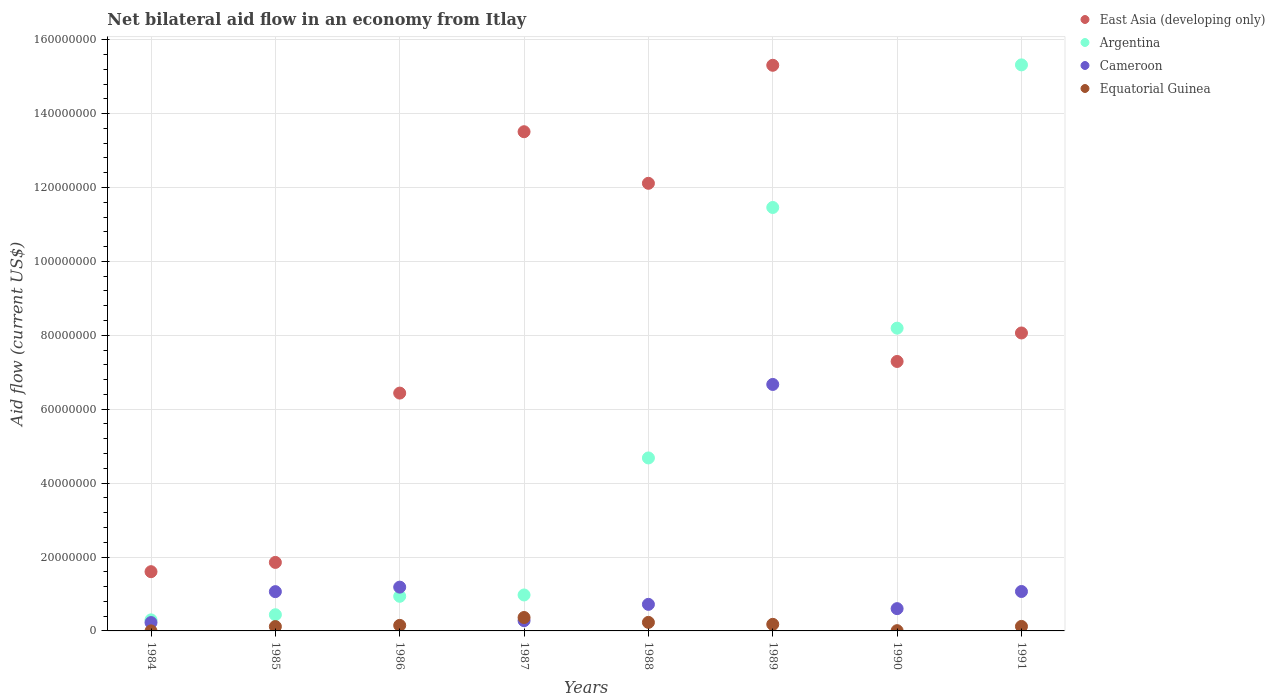How many different coloured dotlines are there?
Your response must be concise. 4. What is the net bilateral aid flow in Equatorial Guinea in 1990?
Give a very brief answer. 7.00e+04. Across all years, what is the maximum net bilateral aid flow in Argentina?
Offer a terse response. 1.53e+08. Across all years, what is the minimum net bilateral aid flow in East Asia (developing only)?
Ensure brevity in your answer.  1.60e+07. In which year was the net bilateral aid flow in Equatorial Guinea maximum?
Offer a very short reply. 1987. What is the total net bilateral aid flow in Cameroon in the graph?
Offer a terse response. 1.18e+08. What is the difference between the net bilateral aid flow in Cameroon in 1984 and that in 1991?
Provide a succinct answer. -8.41e+06. What is the difference between the net bilateral aid flow in Equatorial Guinea in 1991 and the net bilateral aid flow in East Asia (developing only) in 1989?
Make the answer very short. -1.52e+08. What is the average net bilateral aid flow in Cameroon per year?
Provide a succinct answer. 1.48e+07. In the year 1988, what is the difference between the net bilateral aid flow in East Asia (developing only) and net bilateral aid flow in Cameroon?
Make the answer very short. 1.14e+08. In how many years, is the net bilateral aid flow in East Asia (developing only) greater than 152000000 US$?
Your response must be concise. 1. What is the ratio of the net bilateral aid flow in Equatorial Guinea in 1986 to that in 1988?
Give a very brief answer. 0.65. What is the difference between the highest and the second highest net bilateral aid flow in Equatorial Guinea?
Your response must be concise. 1.32e+06. What is the difference between the highest and the lowest net bilateral aid flow in Argentina?
Make the answer very short. 1.50e+08. Is it the case that in every year, the sum of the net bilateral aid flow in East Asia (developing only) and net bilateral aid flow in Equatorial Guinea  is greater than the sum of net bilateral aid flow in Cameroon and net bilateral aid flow in Argentina?
Keep it short and to the point. No. Is the net bilateral aid flow in Equatorial Guinea strictly greater than the net bilateral aid flow in Cameroon over the years?
Ensure brevity in your answer.  No. How many dotlines are there?
Offer a terse response. 4. How many years are there in the graph?
Your answer should be very brief. 8. How many legend labels are there?
Give a very brief answer. 4. How are the legend labels stacked?
Offer a terse response. Vertical. What is the title of the graph?
Give a very brief answer. Net bilateral aid flow in an economy from Itlay. What is the label or title of the X-axis?
Make the answer very short. Years. What is the Aid flow (current US$) of East Asia (developing only) in 1984?
Provide a short and direct response. 1.60e+07. What is the Aid flow (current US$) in Argentina in 1984?
Keep it short and to the point. 2.99e+06. What is the Aid flow (current US$) of Cameroon in 1984?
Your answer should be compact. 2.26e+06. What is the Aid flow (current US$) of East Asia (developing only) in 1985?
Ensure brevity in your answer.  1.85e+07. What is the Aid flow (current US$) of Argentina in 1985?
Your response must be concise. 4.38e+06. What is the Aid flow (current US$) in Cameroon in 1985?
Make the answer very short. 1.06e+07. What is the Aid flow (current US$) in Equatorial Guinea in 1985?
Provide a short and direct response. 1.18e+06. What is the Aid flow (current US$) of East Asia (developing only) in 1986?
Provide a succinct answer. 6.44e+07. What is the Aid flow (current US$) of Argentina in 1986?
Keep it short and to the point. 9.37e+06. What is the Aid flow (current US$) of Cameroon in 1986?
Keep it short and to the point. 1.18e+07. What is the Aid flow (current US$) of Equatorial Guinea in 1986?
Make the answer very short. 1.50e+06. What is the Aid flow (current US$) of East Asia (developing only) in 1987?
Provide a succinct answer. 1.35e+08. What is the Aid flow (current US$) of Argentina in 1987?
Provide a short and direct response. 9.73e+06. What is the Aid flow (current US$) in Cameroon in 1987?
Your answer should be very brief. 2.77e+06. What is the Aid flow (current US$) in Equatorial Guinea in 1987?
Make the answer very short. 3.63e+06. What is the Aid flow (current US$) of East Asia (developing only) in 1988?
Your response must be concise. 1.21e+08. What is the Aid flow (current US$) of Argentina in 1988?
Make the answer very short. 4.68e+07. What is the Aid flow (current US$) of Cameroon in 1988?
Offer a terse response. 7.19e+06. What is the Aid flow (current US$) in Equatorial Guinea in 1988?
Your answer should be very brief. 2.31e+06. What is the Aid flow (current US$) of East Asia (developing only) in 1989?
Give a very brief answer. 1.53e+08. What is the Aid flow (current US$) of Argentina in 1989?
Give a very brief answer. 1.15e+08. What is the Aid flow (current US$) of Cameroon in 1989?
Keep it short and to the point. 6.67e+07. What is the Aid flow (current US$) in Equatorial Guinea in 1989?
Your answer should be compact. 1.78e+06. What is the Aid flow (current US$) in East Asia (developing only) in 1990?
Ensure brevity in your answer.  7.29e+07. What is the Aid flow (current US$) of Argentina in 1990?
Your answer should be compact. 8.19e+07. What is the Aid flow (current US$) of Cameroon in 1990?
Make the answer very short. 6.03e+06. What is the Aid flow (current US$) in Equatorial Guinea in 1990?
Offer a very short reply. 7.00e+04. What is the Aid flow (current US$) in East Asia (developing only) in 1991?
Offer a terse response. 8.06e+07. What is the Aid flow (current US$) in Argentina in 1991?
Offer a very short reply. 1.53e+08. What is the Aid flow (current US$) of Cameroon in 1991?
Your response must be concise. 1.07e+07. What is the Aid flow (current US$) in Equatorial Guinea in 1991?
Your answer should be compact. 1.22e+06. Across all years, what is the maximum Aid flow (current US$) of East Asia (developing only)?
Give a very brief answer. 1.53e+08. Across all years, what is the maximum Aid flow (current US$) in Argentina?
Offer a very short reply. 1.53e+08. Across all years, what is the maximum Aid flow (current US$) in Cameroon?
Your response must be concise. 6.67e+07. Across all years, what is the maximum Aid flow (current US$) in Equatorial Guinea?
Your answer should be compact. 3.63e+06. Across all years, what is the minimum Aid flow (current US$) of East Asia (developing only)?
Give a very brief answer. 1.60e+07. Across all years, what is the minimum Aid flow (current US$) in Argentina?
Offer a terse response. 2.99e+06. Across all years, what is the minimum Aid flow (current US$) in Cameroon?
Make the answer very short. 2.26e+06. Across all years, what is the minimum Aid flow (current US$) of Equatorial Guinea?
Give a very brief answer. 10000. What is the total Aid flow (current US$) in East Asia (developing only) in the graph?
Make the answer very short. 6.62e+08. What is the total Aid flow (current US$) of Argentina in the graph?
Your response must be concise. 4.23e+08. What is the total Aid flow (current US$) in Cameroon in the graph?
Give a very brief answer. 1.18e+08. What is the total Aid flow (current US$) of Equatorial Guinea in the graph?
Offer a terse response. 1.17e+07. What is the difference between the Aid flow (current US$) of East Asia (developing only) in 1984 and that in 1985?
Provide a short and direct response. -2.51e+06. What is the difference between the Aid flow (current US$) of Argentina in 1984 and that in 1985?
Provide a short and direct response. -1.39e+06. What is the difference between the Aid flow (current US$) of Cameroon in 1984 and that in 1985?
Your answer should be compact. -8.37e+06. What is the difference between the Aid flow (current US$) in Equatorial Guinea in 1984 and that in 1985?
Offer a terse response. -1.17e+06. What is the difference between the Aid flow (current US$) in East Asia (developing only) in 1984 and that in 1986?
Offer a very short reply. -4.83e+07. What is the difference between the Aid flow (current US$) of Argentina in 1984 and that in 1986?
Your answer should be very brief. -6.38e+06. What is the difference between the Aid flow (current US$) in Cameroon in 1984 and that in 1986?
Offer a terse response. -9.59e+06. What is the difference between the Aid flow (current US$) in Equatorial Guinea in 1984 and that in 1986?
Offer a terse response. -1.49e+06. What is the difference between the Aid flow (current US$) in East Asia (developing only) in 1984 and that in 1987?
Provide a short and direct response. -1.19e+08. What is the difference between the Aid flow (current US$) in Argentina in 1984 and that in 1987?
Offer a very short reply. -6.74e+06. What is the difference between the Aid flow (current US$) of Cameroon in 1984 and that in 1987?
Make the answer very short. -5.10e+05. What is the difference between the Aid flow (current US$) in Equatorial Guinea in 1984 and that in 1987?
Keep it short and to the point. -3.62e+06. What is the difference between the Aid flow (current US$) of East Asia (developing only) in 1984 and that in 1988?
Ensure brevity in your answer.  -1.05e+08. What is the difference between the Aid flow (current US$) in Argentina in 1984 and that in 1988?
Offer a terse response. -4.38e+07. What is the difference between the Aid flow (current US$) in Cameroon in 1984 and that in 1988?
Offer a very short reply. -4.93e+06. What is the difference between the Aid flow (current US$) in Equatorial Guinea in 1984 and that in 1988?
Give a very brief answer. -2.30e+06. What is the difference between the Aid flow (current US$) of East Asia (developing only) in 1984 and that in 1989?
Offer a very short reply. -1.37e+08. What is the difference between the Aid flow (current US$) of Argentina in 1984 and that in 1989?
Ensure brevity in your answer.  -1.12e+08. What is the difference between the Aid flow (current US$) in Cameroon in 1984 and that in 1989?
Provide a succinct answer. -6.44e+07. What is the difference between the Aid flow (current US$) in Equatorial Guinea in 1984 and that in 1989?
Your response must be concise. -1.77e+06. What is the difference between the Aid flow (current US$) of East Asia (developing only) in 1984 and that in 1990?
Your answer should be very brief. -5.69e+07. What is the difference between the Aid flow (current US$) in Argentina in 1984 and that in 1990?
Give a very brief answer. -7.89e+07. What is the difference between the Aid flow (current US$) of Cameroon in 1984 and that in 1990?
Make the answer very short. -3.77e+06. What is the difference between the Aid flow (current US$) of Equatorial Guinea in 1984 and that in 1990?
Provide a short and direct response. -6.00e+04. What is the difference between the Aid flow (current US$) in East Asia (developing only) in 1984 and that in 1991?
Offer a very short reply. -6.46e+07. What is the difference between the Aid flow (current US$) of Argentina in 1984 and that in 1991?
Offer a very short reply. -1.50e+08. What is the difference between the Aid flow (current US$) in Cameroon in 1984 and that in 1991?
Provide a succinct answer. -8.41e+06. What is the difference between the Aid flow (current US$) in Equatorial Guinea in 1984 and that in 1991?
Provide a short and direct response. -1.21e+06. What is the difference between the Aid flow (current US$) of East Asia (developing only) in 1985 and that in 1986?
Your response must be concise. -4.58e+07. What is the difference between the Aid flow (current US$) in Argentina in 1985 and that in 1986?
Ensure brevity in your answer.  -4.99e+06. What is the difference between the Aid flow (current US$) in Cameroon in 1985 and that in 1986?
Your response must be concise. -1.22e+06. What is the difference between the Aid flow (current US$) in Equatorial Guinea in 1985 and that in 1986?
Provide a short and direct response. -3.20e+05. What is the difference between the Aid flow (current US$) of East Asia (developing only) in 1985 and that in 1987?
Keep it short and to the point. -1.17e+08. What is the difference between the Aid flow (current US$) in Argentina in 1985 and that in 1987?
Your response must be concise. -5.35e+06. What is the difference between the Aid flow (current US$) of Cameroon in 1985 and that in 1987?
Ensure brevity in your answer.  7.86e+06. What is the difference between the Aid flow (current US$) of Equatorial Guinea in 1985 and that in 1987?
Your response must be concise. -2.45e+06. What is the difference between the Aid flow (current US$) of East Asia (developing only) in 1985 and that in 1988?
Make the answer very short. -1.03e+08. What is the difference between the Aid flow (current US$) of Argentina in 1985 and that in 1988?
Offer a very short reply. -4.24e+07. What is the difference between the Aid flow (current US$) in Cameroon in 1985 and that in 1988?
Keep it short and to the point. 3.44e+06. What is the difference between the Aid flow (current US$) of Equatorial Guinea in 1985 and that in 1988?
Give a very brief answer. -1.13e+06. What is the difference between the Aid flow (current US$) of East Asia (developing only) in 1985 and that in 1989?
Offer a very short reply. -1.35e+08. What is the difference between the Aid flow (current US$) in Argentina in 1985 and that in 1989?
Offer a terse response. -1.10e+08. What is the difference between the Aid flow (current US$) in Cameroon in 1985 and that in 1989?
Your answer should be compact. -5.61e+07. What is the difference between the Aid flow (current US$) of Equatorial Guinea in 1985 and that in 1989?
Keep it short and to the point. -6.00e+05. What is the difference between the Aid flow (current US$) of East Asia (developing only) in 1985 and that in 1990?
Offer a very short reply. -5.44e+07. What is the difference between the Aid flow (current US$) in Argentina in 1985 and that in 1990?
Ensure brevity in your answer.  -7.76e+07. What is the difference between the Aid flow (current US$) of Cameroon in 1985 and that in 1990?
Give a very brief answer. 4.60e+06. What is the difference between the Aid flow (current US$) in Equatorial Guinea in 1985 and that in 1990?
Provide a succinct answer. 1.11e+06. What is the difference between the Aid flow (current US$) of East Asia (developing only) in 1985 and that in 1991?
Your answer should be compact. -6.21e+07. What is the difference between the Aid flow (current US$) in Argentina in 1985 and that in 1991?
Your response must be concise. -1.49e+08. What is the difference between the Aid flow (current US$) of Cameroon in 1985 and that in 1991?
Ensure brevity in your answer.  -4.00e+04. What is the difference between the Aid flow (current US$) of East Asia (developing only) in 1986 and that in 1987?
Offer a very short reply. -7.07e+07. What is the difference between the Aid flow (current US$) of Argentina in 1986 and that in 1987?
Provide a succinct answer. -3.60e+05. What is the difference between the Aid flow (current US$) of Cameroon in 1986 and that in 1987?
Your answer should be very brief. 9.08e+06. What is the difference between the Aid flow (current US$) in Equatorial Guinea in 1986 and that in 1987?
Make the answer very short. -2.13e+06. What is the difference between the Aid flow (current US$) in East Asia (developing only) in 1986 and that in 1988?
Make the answer very short. -5.68e+07. What is the difference between the Aid flow (current US$) of Argentina in 1986 and that in 1988?
Ensure brevity in your answer.  -3.74e+07. What is the difference between the Aid flow (current US$) of Cameroon in 1986 and that in 1988?
Your answer should be very brief. 4.66e+06. What is the difference between the Aid flow (current US$) in Equatorial Guinea in 1986 and that in 1988?
Your answer should be very brief. -8.10e+05. What is the difference between the Aid flow (current US$) in East Asia (developing only) in 1986 and that in 1989?
Provide a succinct answer. -8.87e+07. What is the difference between the Aid flow (current US$) of Argentina in 1986 and that in 1989?
Give a very brief answer. -1.05e+08. What is the difference between the Aid flow (current US$) in Cameroon in 1986 and that in 1989?
Provide a succinct answer. -5.48e+07. What is the difference between the Aid flow (current US$) of Equatorial Guinea in 1986 and that in 1989?
Your response must be concise. -2.80e+05. What is the difference between the Aid flow (current US$) in East Asia (developing only) in 1986 and that in 1990?
Offer a very short reply. -8.56e+06. What is the difference between the Aid flow (current US$) of Argentina in 1986 and that in 1990?
Provide a short and direct response. -7.26e+07. What is the difference between the Aid flow (current US$) in Cameroon in 1986 and that in 1990?
Offer a very short reply. 5.82e+06. What is the difference between the Aid flow (current US$) in Equatorial Guinea in 1986 and that in 1990?
Provide a short and direct response. 1.43e+06. What is the difference between the Aid flow (current US$) of East Asia (developing only) in 1986 and that in 1991?
Make the answer very short. -1.63e+07. What is the difference between the Aid flow (current US$) in Argentina in 1986 and that in 1991?
Provide a succinct answer. -1.44e+08. What is the difference between the Aid flow (current US$) in Cameroon in 1986 and that in 1991?
Your answer should be compact. 1.18e+06. What is the difference between the Aid flow (current US$) of Equatorial Guinea in 1986 and that in 1991?
Make the answer very short. 2.80e+05. What is the difference between the Aid flow (current US$) in East Asia (developing only) in 1987 and that in 1988?
Offer a very short reply. 1.40e+07. What is the difference between the Aid flow (current US$) of Argentina in 1987 and that in 1988?
Give a very brief answer. -3.71e+07. What is the difference between the Aid flow (current US$) of Cameroon in 1987 and that in 1988?
Offer a terse response. -4.42e+06. What is the difference between the Aid flow (current US$) in Equatorial Guinea in 1987 and that in 1988?
Provide a short and direct response. 1.32e+06. What is the difference between the Aid flow (current US$) of East Asia (developing only) in 1987 and that in 1989?
Offer a very short reply. -1.80e+07. What is the difference between the Aid flow (current US$) in Argentina in 1987 and that in 1989?
Your response must be concise. -1.05e+08. What is the difference between the Aid flow (current US$) of Cameroon in 1987 and that in 1989?
Make the answer very short. -6.39e+07. What is the difference between the Aid flow (current US$) in Equatorial Guinea in 1987 and that in 1989?
Give a very brief answer. 1.85e+06. What is the difference between the Aid flow (current US$) in East Asia (developing only) in 1987 and that in 1990?
Give a very brief answer. 6.22e+07. What is the difference between the Aid flow (current US$) of Argentina in 1987 and that in 1990?
Ensure brevity in your answer.  -7.22e+07. What is the difference between the Aid flow (current US$) of Cameroon in 1987 and that in 1990?
Your answer should be compact. -3.26e+06. What is the difference between the Aid flow (current US$) of Equatorial Guinea in 1987 and that in 1990?
Offer a very short reply. 3.56e+06. What is the difference between the Aid flow (current US$) of East Asia (developing only) in 1987 and that in 1991?
Provide a succinct answer. 5.45e+07. What is the difference between the Aid flow (current US$) in Argentina in 1987 and that in 1991?
Ensure brevity in your answer.  -1.43e+08. What is the difference between the Aid flow (current US$) in Cameroon in 1987 and that in 1991?
Keep it short and to the point. -7.90e+06. What is the difference between the Aid flow (current US$) of Equatorial Guinea in 1987 and that in 1991?
Your answer should be compact. 2.41e+06. What is the difference between the Aid flow (current US$) in East Asia (developing only) in 1988 and that in 1989?
Offer a terse response. -3.19e+07. What is the difference between the Aid flow (current US$) in Argentina in 1988 and that in 1989?
Your answer should be very brief. -6.78e+07. What is the difference between the Aid flow (current US$) in Cameroon in 1988 and that in 1989?
Your answer should be compact. -5.95e+07. What is the difference between the Aid flow (current US$) in Equatorial Guinea in 1988 and that in 1989?
Your answer should be very brief. 5.30e+05. What is the difference between the Aid flow (current US$) of East Asia (developing only) in 1988 and that in 1990?
Ensure brevity in your answer.  4.82e+07. What is the difference between the Aid flow (current US$) in Argentina in 1988 and that in 1990?
Your response must be concise. -3.51e+07. What is the difference between the Aid flow (current US$) of Cameroon in 1988 and that in 1990?
Your answer should be very brief. 1.16e+06. What is the difference between the Aid flow (current US$) in Equatorial Guinea in 1988 and that in 1990?
Ensure brevity in your answer.  2.24e+06. What is the difference between the Aid flow (current US$) in East Asia (developing only) in 1988 and that in 1991?
Offer a very short reply. 4.05e+07. What is the difference between the Aid flow (current US$) of Argentina in 1988 and that in 1991?
Make the answer very short. -1.06e+08. What is the difference between the Aid flow (current US$) of Cameroon in 1988 and that in 1991?
Keep it short and to the point. -3.48e+06. What is the difference between the Aid flow (current US$) of Equatorial Guinea in 1988 and that in 1991?
Give a very brief answer. 1.09e+06. What is the difference between the Aid flow (current US$) in East Asia (developing only) in 1989 and that in 1990?
Ensure brevity in your answer.  8.02e+07. What is the difference between the Aid flow (current US$) of Argentina in 1989 and that in 1990?
Your response must be concise. 3.27e+07. What is the difference between the Aid flow (current US$) of Cameroon in 1989 and that in 1990?
Provide a succinct answer. 6.07e+07. What is the difference between the Aid flow (current US$) of Equatorial Guinea in 1989 and that in 1990?
Provide a short and direct response. 1.71e+06. What is the difference between the Aid flow (current US$) in East Asia (developing only) in 1989 and that in 1991?
Keep it short and to the point. 7.24e+07. What is the difference between the Aid flow (current US$) of Argentina in 1989 and that in 1991?
Offer a very short reply. -3.86e+07. What is the difference between the Aid flow (current US$) of Cameroon in 1989 and that in 1991?
Your answer should be very brief. 5.60e+07. What is the difference between the Aid flow (current US$) in Equatorial Guinea in 1989 and that in 1991?
Offer a very short reply. 5.60e+05. What is the difference between the Aid flow (current US$) of East Asia (developing only) in 1990 and that in 1991?
Offer a terse response. -7.71e+06. What is the difference between the Aid flow (current US$) of Argentina in 1990 and that in 1991?
Offer a very short reply. -7.12e+07. What is the difference between the Aid flow (current US$) in Cameroon in 1990 and that in 1991?
Your answer should be very brief. -4.64e+06. What is the difference between the Aid flow (current US$) of Equatorial Guinea in 1990 and that in 1991?
Make the answer very short. -1.15e+06. What is the difference between the Aid flow (current US$) of East Asia (developing only) in 1984 and the Aid flow (current US$) of Argentina in 1985?
Provide a succinct answer. 1.16e+07. What is the difference between the Aid flow (current US$) in East Asia (developing only) in 1984 and the Aid flow (current US$) in Cameroon in 1985?
Give a very brief answer. 5.40e+06. What is the difference between the Aid flow (current US$) of East Asia (developing only) in 1984 and the Aid flow (current US$) of Equatorial Guinea in 1985?
Offer a very short reply. 1.48e+07. What is the difference between the Aid flow (current US$) of Argentina in 1984 and the Aid flow (current US$) of Cameroon in 1985?
Ensure brevity in your answer.  -7.64e+06. What is the difference between the Aid flow (current US$) in Argentina in 1984 and the Aid flow (current US$) in Equatorial Guinea in 1985?
Keep it short and to the point. 1.81e+06. What is the difference between the Aid flow (current US$) of Cameroon in 1984 and the Aid flow (current US$) of Equatorial Guinea in 1985?
Make the answer very short. 1.08e+06. What is the difference between the Aid flow (current US$) of East Asia (developing only) in 1984 and the Aid flow (current US$) of Argentina in 1986?
Your answer should be very brief. 6.66e+06. What is the difference between the Aid flow (current US$) in East Asia (developing only) in 1984 and the Aid flow (current US$) in Cameroon in 1986?
Make the answer very short. 4.18e+06. What is the difference between the Aid flow (current US$) in East Asia (developing only) in 1984 and the Aid flow (current US$) in Equatorial Guinea in 1986?
Your answer should be compact. 1.45e+07. What is the difference between the Aid flow (current US$) of Argentina in 1984 and the Aid flow (current US$) of Cameroon in 1986?
Make the answer very short. -8.86e+06. What is the difference between the Aid flow (current US$) of Argentina in 1984 and the Aid flow (current US$) of Equatorial Guinea in 1986?
Provide a short and direct response. 1.49e+06. What is the difference between the Aid flow (current US$) in Cameroon in 1984 and the Aid flow (current US$) in Equatorial Guinea in 1986?
Provide a short and direct response. 7.60e+05. What is the difference between the Aid flow (current US$) in East Asia (developing only) in 1984 and the Aid flow (current US$) in Argentina in 1987?
Your response must be concise. 6.30e+06. What is the difference between the Aid flow (current US$) of East Asia (developing only) in 1984 and the Aid flow (current US$) of Cameroon in 1987?
Make the answer very short. 1.33e+07. What is the difference between the Aid flow (current US$) of East Asia (developing only) in 1984 and the Aid flow (current US$) of Equatorial Guinea in 1987?
Ensure brevity in your answer.  1.24e+07. What is the difference between the Aid flow (current US$) in Argentina in 1984 and the Aid flow (current US$) in Cameroon in 1987?
Ensure brevity in your answer.  2.20e+05. What is the difference between the Aid flow (current US$) in Argentina in 1984 and the Aid flow (current US$) in Equatorial Guinea in 1987?
Offer a terse response. -6.40e+05. What is the difference between the Aid flow (current US$) in Cameroon in 1984 and the Aid flow (current US$) in Equatorial Guinea in 1987?
Provide a short and direct response. -1.37e+06. What is the difference between the Aid flow (current US$) of East Asia (developing only) in 1984 and the Aid flow (current US$) of Argentina in 1988?
Your response must be concise. -3.08e+07. What is the difference between the Aid flow (current US$) in East Asia (developing only) in 1984 and the Aid flow (current US$) in Cameroon in 1988?
Give a very brief answer. 8.84e+06. What is the difference between the Aid flow (current US$) in East Asia (developing only) in 1984 and the Aid flow (current US$) in Equatorial Guinea in 1988?
Your response must be concise. 1.37e+07. What is the difference between the Aid flow (current US$) of Argentina in 1984 and the Aid flow (current US$) of Cameroon in 1988?
Provide a short and direct response. -4.20e+06. What is the difference between the Aid flow (current US$) of Argentina in 1984 and the Aid flow (current US$) of Equatorial Guinea in 1988?
Offer a terse response. 6.80e+05. What is the difference between the Aid flow (current US$) of East Asia (developing only) in 1984 and the Aid flow (current US$) of Argentina in 1989?
Offer a terse response. -9.86e+07. What is the difference between the Aid flow (current US$) in East Asia (developing only) in 1984 and the Aid flow (current US$) in Cameroon in 1989?
Your answer should be compact. -5.07e+07. What is the difference between the Aid flow (current US$) in East Asia (developing only) in 1984 and the Aid flow (current US$) in Equatorial Guinea in 1989?
Your answer should be compact. 1.42e+07. What is the difference between the Aid flow (current US$) of Argentina in 1984 and the Aid flow (current US$) of Cameroon in 1989?
Offer a very short reply. -6.37e+07. What is the difference between the Aid flow (current US$) of Argentina in 1984 and the Aid flow (current US$) of Equatorial Guinea in 1989?
Ensure brevity in your answer.  1.21e+06. What is the difference between the Aid flow (current US$) in East Asia (developing only) in 1984 and the Aid flow (current US$) in Argentina in 1990?
Your response must be concise. -6.59e+07. What is the difference between the Aid flow (current US$) of East Asia (developing only) in 1984 and the Aid flow (current US$) of Equatorial Guinea in 1990?
Keep it short and to the point. 1.60e+07. What is the difference between the Aid flow (current US$) in Argentina in 1984 and the Aid flow (current US$) in Cameroon in 1990?
Ensure brevity in your answer.  -3.04e+06. What is the difference between the Aid flow (current US$) of Argentina in 1984 and the Aid flow (current US$) of Equatorial Guinea in 1990?
Offer a very short reply. 2.92e+06. What is the difference between the Aid flow (current US$) of Cameroon in 1984 and the Aid flow (current US$) of Equatorial Guinea in 1990?
Offer a very short reply. 2.19e+06. What is the difference between the Aid flow (current US$) in East Asia (developing only) in 1984 and the Aid flow (current US$) in Argentina in 1991?
Offer a very short reply. -1.37e+08. What is the difference between the Aid flow (current US$) of East Asia (developing only) in 1984 and the Aid flow (current US$) of Cameroon in 1991?
Provide a short and direct response. 5.36e+06. What is the difference between the Aid flow (current US$) in East Asia (developing only) in 1984 and the Aid flow (current US$) in Equatorial Guinea in 1991?
Keep it short and to the point. 1.48e+07. What is the difference between the Aid flow (current US$) of Argentina in 1984 and the Aid flow (current US$) of Cameroon in 1991?
Your answer should be very brief. -7.68e+06. What is the difference between the Aid flow (current US$) in Argentina in 1984 and the Aid flow (current US$) in Equatorial Guinea in 1991?
Your response must be concise. 1.77e+06. What is the difference between the Aid flow (current US$) in Cameroon in 1984 and the Aid flow (current US$) in Equatorial Guinea in 1991?
Give a very brief answer. 1.04e+06. What is the difference between the Aid flow (current US$) of East Asia (developing only) in 1985 and the Aid flow (current US$) of Argentina in 1986?
Your response must be concise. 9.17e+06. What is the difference between the Aid flow (current US$) in East Asia (developing only) in 1985 and the Aid flow (current US$) in Cameroon in 1986?
Your answer should be compact. 6.69e+06. What is the difference between the Aid flow (current US$) in East Asia (developing only) in 1985 and the Aid flow (current US$) in Equatorial Guinea in 1986?
Give a very brief answer. 1.70e+07. What is the difference between the Aid flow (current US$) in Argentina in 1985 and the Aid flow (current US$) in Cameroon in 1986?
Ensure brevity in your answer.  -7.47e+06. What is the difference between the Aid flow (current US$) in Argentina in 1985 and the Aid flow (current US$) in Equatorial Guinea in 1986?
Your answer should be very brief. 2.88e+06. What is the difference between the Aid flow (current US$) in Cameroon in 1985 and the Aid flow (current US$) in Equatorial Guinea in 1986?
Ensure brevity in your answer.  9.13e+06. What is the difference between the Aid flow (current US$) in East Asia (developing only) in 1985 and the Aid flow (current US$) in Argentina in 1987?
Give a very brief answer. 8.81e+06. What is the difference between the Aid flow (current US$) in East Asia (developing only) in 1985 and the Aid flow (current US$) in Cameroon in 1987?
Give a very brief answer. 1.58e+07. What is the difference between the Aid flow (current US$) of East Asia (developing only) in 1985 and the Aid flow (current US$) of Equatorial Guinea in 1987?
Provide a short and direct response. 1.49e+07. What is the difference between the Aid flow (current US$) of Argentina in 1985 and the Aid flow (current US$) of Cameroon in 1987?
Offer a terse response. 1.61e+06. What is the difference between the Aid flow (current US$) in Argentina in 1985 and the Aid flow (current US$) in Equatorial Guinea in 1987?
Your answer should be very brief. 7.50e+05. What is the difference between the Aid flow (current US$) in East Asia (developing only) in 1985 and the Aid flow (current US$) in Argentina in 1988?
Offer a terse response. -2.83e+07. What is the difference between the Aid flow (current US$) of East Asia (developing only) in 1985 and the Aid flow (current US$) of Cameroon in 1988?
Offer a terse response. 1.14e+07. What is the difference between the Aid flow (current US$) of East Asia (developing only) in 1985 and the Aid flow (current US$) of Equatorial Guinea in 1988?
Give a very brief answer. 1.62e+07. What is the difference between the Aid flow (current US$) of Argentina in 1985 and the Aid flow (current US$) of Cameroon in 1988?
Make the answer very short. -2.81e+06. What is the difference between the Aid flow (current US$) in Argentina in 1985 and the Aid flow (current US$) in Equatorial Guinea in 1988?
Give a very brief answer. 2.07e+06. What is the difference between the Aid flow (current US$) of Cameroon in 1985 and the Aid flow (current US$) of Equatorial Guinea in 1988?
Ensure brevity in your answer.  8.32e+06. What is the difference between the Aid flow (current US$) of East Asia (developing only) in 1985 and the Aid flow (current US$) of Argentina in 1989?
Provide a succinct answer. -9.60e+07. What is the difference between the Aid flow (current US$) in East Asia (developing only) in 1985 and the Aid flow (current US$) in Cameroon in 1989?
Offer a terse response. -4.82e+07. What is the difference between the Aid flow (current US$) of East Asia (developing only) in 1985 and the Aid flow (current US$) of Equatorial Guinea in 1989?
Offer a terse response. 1.68e+07. What is the difference between the Aid flow (current US$) in Argentina in 1985 and the Aid flow (current US$) in Cameroon in 1989?
Offer a very short reply. -6.23e+07. What is the difference between the Aid flow (current US$) of Argentina in 1985 and the Aid flow (current US$) of Equatorial Guinea in 1989?
Offer a very short reply. 2.60e+06. What is the difference between the Aid flow (current US$) of Cameroon in 1985 and the Aid flow (current US$) of Equatorial Guinea in 1989?
Give a very brief answer. 8.85e+06. What is the difference between the Aid flow (current US$) of East Asia (developing only) in 1985 and the Aid flow (current US$) of Argentina in 1990?
Ensure brevity in your answer.  -6.34e+07. What is the difference between the Aid flow (current US$) in East Asia (developing only) in 1985 and the Aid flow (current US$) in Cameroon in 1990?
Make the answer very short. 1.25e+07. What is the difference between the Aid flow (current US$) of East Asia (developing only) in 1985 and the Aid flow (current US$) of Equatorial Guinea in 1990?
Keep it short and to the point. 1.85e+07. What is the difference between the Aid flow (current US$) of Argentina in 1985 and the Aid flow (current US$) of Cameroon in 1990?
Your answer should be very brief. -1.65e+06. What is the difference between the Aid flow (current US$) in Argentina in 1985 and the Aid flow (current US$) in Equatorial Guinea in 1990?
Give a very brief answer. 4.31e+06. What is the difference between the Aid flow (current US$) in Cameroon in 1985 and the Aid flow (current US$) in Equatorial Guinea in 1990?
Provide a short and direct response. 1.06e+07. What is the difference between the Aid flow (current US$) of East Asia (developing only) in 1985 and the Aid flow (current US$) of Argentina in 1991?
Provide a short and direct response. -1.35e+08. What is the difference between the Aid flow (current US$) in East Asia (developing only) in 1985 and the Aid flow (current US$) in Cameroon in 1991?
Your answer should be very brief. 7.87e+06. What is the difference between the Aid flow (current US$) in East Asia (developing only) in 1985 and the Aid flow (current US$) in Equatorial Guinea in 1991?
Your answer should be compact. 1.73e+07. What is the difference between the Aid flow (current US$) of Argentina in 1985 and the Aid flow (current US$) of Cameroon in 1991?
Provide a succinct answer. -6.29e+06. What is the difference between the Aid flow (current US$) of Argentina in 1985 and the Aid flow (current US$) of Equatorial Guinea in 1991?
Give a very brief answer. 3.16e+06. What is the difference between the Aid flow (current US$) in Cameroon in 1985 and the Aid flow (current US$) in Equatorial Guinea in 1991?
Keep it short and to the point. 9.41e+06. What is the difference between the Aid flow (current US$) in East Asia (developing only) in 1986 and the Aid flow (current US$) in Argentina in 1987?
Your response must be concise. 5.46e+07. What is the difference between the Aid flow (current US$) of East Asia (developing only) in 1986 and the Aid flow (current US$) of Cameroon in 1987?
Ensure brevity in your answer.  6.16e+07. What is the difference between the Aid flow (current US$) in East Asia (developing only) in 1986 and the Aid flow (current US$) in Equatorial Guinea in 1987?
Provide a short and direct response. 6.07e+07. What is the difference between the Aid flow (current US$) of Argentina in 1986 and the Aid flow (current US$) of Cameroon in 1987?
Your response must be concise. 6.60e+06. What is the difference between the Aid flow (current US$) in Argentina in 1986 and the Aid flow (current US$) in Equatorial Guinea in 1987?
Give a very brief answer. 5.74e+06. What is the difference between the Aid flow (current US$) in Cameroon in 1986 and the Aid flow (current US$) in Equatorial Guinea in 1987?
Your response must be concise. 8.22e+06. What is the difference between the Aid flow (current US$) in East Asia (developing only) in 1986 and the Aid flow (current US$) in Argentina in 1988?
Give a very brief answer. 1.76e+07. What is the difference between the Aid flow (current US$) in East Asia (developing only) in 1986 and the Aid flow (current US$) in Cameroon in 1988?
Give a very brief answer. 5.72e+07. What is the difference between the Aid flow (current US$) in East Asia (developing only) in 1986 and the Aid flow (current US$) in Equatorial Guinea in 1988?
Ensure brevity in your answer.  6.20e+07. What is the difference between the Aid flow (current US$) of Argentina in 1986 and the Aid flow (current US$) of Cameroon in 1988?
Provide a succinct answer. 2.18e+06. What is the difference between the Aid flow (current US$) of Argentina in 1986 and the Aid flow (current US$) of Equatorial Guinea in 1988?
Give a very brief answer. 7.06e+06. What is the difference between the Aid flow (current US$) of Cameroon in 1986 and the Aid flow (current US$) of Equatorial Guinea in 1988?
Provide a succinct answer. 9.54e+06. What is the difference between the Aid flow (current US$) of East Asia (developing only) in 1986 and the Aid flow (current US$) of Argentina in 1989?
Ensure brevity in your answer.  -5.02e+07. What is the difference between the Aid flow (current US$) in East Asia (developing only) in 1986 and the Aid flow (current US$) in Cameroon in 1989?
Provide a succinct answer. -2.34e+06. What is the difference between the Aid flow (current US$) in East Asia (developing only) in 1986 and the Aid flow (current US$) in Equatorial Guinea in 1989?
Provide a succinct answer. 6.26e+07. What is the difference between the Aid flow (current US$) of Argentina in 1986 and the Aid flow (current US$) of Cameroon in 1989?
Offer a very short reply. -5.73e+07. What is the difference between the Aid flow (current US$) in Argentina in 1986 and the Aid flow (current US$) in Equatorial Guinea in 1989?
Make the answer very short. 7.59e+06. What is the difference between the Aid flow (current US$) of Cameroon in 1986 and the Aid flow (current US$) of Equatorial Guinea in 1989?
Make the answer very short. 1.01e+07. What is the difference between the Aid flow (current US$) of East Asia (developing only) in 1986 and the Aid flow (current US$) of Argentina in 1990?
Keep it short and to the point. -1.76e+07. What is the difference between the Aid flow (current US$) of East Asia (developing only) in 1986 and the Aid flow (current US$) of Cameroon in 1990?
Your response must be concise. 5.83e+07. What is the difference between the Aid flow (current US$) of East Asia (developing only) in 1986 and the Aid flow (current US$) of Equatorial Guinea in 1990?
Your answer should be very brief. 6.43e+07. What is the difference between the Aid flow (current US$) in Argentina in 1986 and the Aid flow (current US$) in Cameroon in 1990?
Offer a very short reply. 3.34e+06. What is the difference between the Aid flow (current US$) of Argentina in 1986 and the Aid flow (current US$) of Equatorial Guinea in 1990?
Your answer should be very brief. 9.30e+06. What is the difference between the Aid flow (current US$) of Cameroon in 1986 and the Aid flow (current US$) of Equatorial Guinea in 1990?
Provide a succinct answer. 1.18e+07. What is the difference between the Aid flow (current US$) of East Asia (developing only) in 1986 and the Aid flow (current US$) of Argentina in 1991?
Offer a terse response. -8.88e+07. What is the difference between the Aid flow (current US$) of East Asia (developing only) in 1986 and the Aid flow (current US$) of Cameroon in 1991?
Offer a very short reply. 5.37e+07. What is the difference between the Aid flow (current US$) in East Asia (developing only) in 1986 and the Aid flow (current US$) in Equatorial Guinea in 1991?
Offer a terse response. 6.31e+07. What is the difference between the Aid flow (current US$) in Argentina in 1986 and the Aid flow (current US$) in Cameroon in 1991?
Offer a terse response. -1.30e+06. What is the difference between the Aid flow (current US$) in Argentina in 1986 and the Aid flow (current US$) in Equatorial Guinea in 1991?
Offer a terse response. 8.15e+06. What is the difference between the Aid flow (current US$) of Cameroon in 1986 and the Aid flow (current US$) of Equatorial Guinea in 1991?
Give a very brief answer. 1.06e+07. What is the difference between the Aid flow (current US$) in East Asia (developing only) in 1987 and the Aid flow (current US$) in Argentina in 1988?
Give a very brief answer. 8.83e+07. What is the difference between the Aid flow (current US$) in East Asia (developing only) in 1987 and the Aid flow (current US$) in Cameroon in 1988?
Offer a terse response. 1.28e+08. What is the difference between the Aid flow (current US$) of East Asia (developing only) in 1987 and the Aid flow (current US$) of Equatorial Guinea in 1988?
Give a very brief answer. 1.33e+08. What is the difference between the Aid flow (current US$) of Argentina in 1987 and the Aid flow (current US$) of Cameroon in 1988?
Provide a short and direct response. 2.54e+06. What is the difference between the Aid flow (current US$) of Argentina in 1987 and the Aid flow (current US$) of Equatorial Guinea in 1988?
Provide a succinct answer. 7.42e+06. What is the difference between the Aid flow (current US$) of Cameroon in 1987 and the Aid flow (current US$) of Equatorial Guinea in 1988?
Provide a succinct answer. 4.60e+05. What is the difference between the Aid flow (current US$) in East Asia (developing only) in 1987 and the Aid flow (current US$) in Argentina in 1989?
Make the answer very short. 2.05e+07. What is the difference between the Aid flow (current US$) of East Asia (developing only) in 1987 and the Aid flow (current US$) of Cameroon in 1989?
Provide a short and direct response. 6.84e+07. What is the difference between the Aid flow (current US$) in East Asia (developing only) in 1987 and the Aid flow (current US$) in Equatorial Guinea in 1989?
Ensure brevity in your answer.  1.33e+08. What is the difference between the Aid flow (current US$) in Argentina in 1987 and the Aid flow (current US$) in Cameroon in 1989?
Keep it short and to the point. -5.70e+07. What is the difference between the Aid flow (current US$) in Argentina in 1987 and the Aid flow (current US$) in Equatorial Guinea in 1989?
Your answer should be compact. 7.95e+06. What is the difference between the Aid flow (current US$) of Cameroon in 1987 and the Aid flow (current US$) of Equatorial Guinea in 1989?
Your answer should be compact. 9.90e+05. What is the difference between the Aid flow (current US$) of East Asia (developing only) in 1987 and the Aid flow (current US$) of Argentina in 1990?
Keep it short and to the point. 5.32e+07. What is the difference between the Aid flow (current US$) in East Asia (developing only) in 1987 and the Aid flow (current US$) in Cameroon in 1990?
Your response must be concise. 1.29e+08. What is the difference between the Aid flow (current US$) of East Asia (developing only) in 1987 and the Aid flow (current US$) of Equatorial Guinea in 1990?
Your answer should be compact. 1.35e+08. What is the difference between the Aid flow (current US$) in Argentina in 1987 and the Aid flow (current US$) in Cameroon in 1990?
Provide a succinct answer. 3.70e+06. What is the difference between the Aid flow (current US$) of Argentina in 1987 and the Aid flow (current US$) of Equatorial Guinea in 1990?
Provide a short and direct response. 9.66e+06. What is the difference between the Aid flow (current US$) of Cameroon in 1987 and the Aid flow (current US$) of Equatorial Guinea in 1990?
Provide a short and direct response. 2.70e+06. What is the difference between the Aid flow (current US$) in East Asia (developing only) in 1987 and the Aid flow (current US$) in Argentina in 1991?
Keep it short and to the point. -1.81e+07. What is the difference between the Aid flow (current US$) in East Asia (developing only) in 1987 and the Aid flow (current US$) in Cameroon in 1991?
Offer a very short reply. 1.24e+08. What is the difference between the Aid flow (current US$) in East Asia (developing only) in 1987 and the Aid flow (current US$) in Equatorial Guinea in 1991?
Provide a succinct answer. 1.34e+08. What is the difference between the Aid flow (current US$) of Argentina in 1987 and the Aid flow (current US$) of Cameroon in 1991?
Ensure brevity in your answer.  -9.40e+05. What is the difference between the Aid flow (current US$) in Argentina in 1987 and the Aid flow (current US$) in Equatorial Guinea in 1991?
Keep it short and to the point. 8.51e+06. What is the difference between the Aid flow (current US$) of Cameroon in 1987 and the Aid flow (current US$) of Equatorial Guinea in 1991?
Provide a succinct answer. 1.55e+06. What is the difference between the Aid flow (current US$) of East Asia (developing only) in 1988 and the Aid flow (current US$) of Argentina in 1989?
Offer a terse response. 6.54e+06. What is the difference between the Aid flow (current US$) of East Asia (developing only) in 1988 and the Aid flow (current US$) of Cameroon in 1989?
Keep it short and to the point. 5.44e+07. What is the difference between the Aid flow (current US$) of East Asia (developing only) in 1988 and the Aid flow (current US$) of Equatorial Guinea in 1989?
Your response must be concise. 1.19e+08. What is the difference between the Aid flow (current US$) in Argentina in 1988 and the Aid flow (current US$) in Cameroon in 1989?
Your answer should be very brief. -1.99e+07. What is the difference between the Aid flow (current US$) of Argentina in 1988 and the Aid flow (current US$) of Equatorial Guinea in 1989?
Your answer should be very brief. 4.50e+07. What is the difference between the Aid flow (current US$) in Cameroon in 1988 and the Aid flow (current US$) in Equatorial Guinea in 1989?
Offer a very short reply. 5.41e+06. What is the difference between the Aid flow (current US$) of East Asia (developing only) in 1988 and the Aid flow (current US$) of Argentina in 1990?
Your answer should be very brief. 3.92e+07. What is the difference between the Aid flow (current US$) in East Asia (developing only) in 1988 and the Aid flow (current US$) in Cameroon in 1990?
Offer a very short reply. 1.15e+08. What is the difference between the Aid flow (current US$) in East Asia (developing only) in 1988 and the Aid flow (current US$) in Equatorial Guinea in 1990?
Your response must be concise. 1.21e+08. What is the difference between the Aid flow (current US$) in Argentina in 1988 and the Aid flow (current US$) in Cameroon in 1990?
Offer a very short reply. 4.08e+07. What is the difference between the Aid flow (current US$) of Argentina in 1988 and the Aid flow (current US$) of Equatorial Guinea in 1990?
Your answer should be very brief. 4.67e+07. What is the difference between the Aid flow (current US$) in Cameroon in 1988 and the Aid flow (current US$) in Equatorial Guinea in 1990?
Offer a terse response. 7.12e+06. What is the difference between the Aid flow (current US$) in East Asia (developing only) in 1988 and the Aid flow (current US$) in Argentina in 1991?
Keep it short and to the point. -3.20e+07. What is the difference between the Aid flow (current US$) of East Asia (developing only) in 1988 and the Aid flow (current US$) of Cameroon in 1991?
Your answer should be very brief. 1.10e+08. What is the difference between the Aid flow (current US$) of East Asia (developing only) in 1988 and the Aid flow (current US$) of Equatorial Guinea in 1991?
Offer a terse response. 1.20e+08. What is the difference between the Aid flow (current US$) in Argentina in 1988 and the Aid flow (current US$) in Cameroon in 1991?
Offer a very short reply. 3.61e+07. What is the difference between the Aid flow (current US$) in Argentina in 1988 and the Aid flow (current US$) in Equatorial Guinea in 1991?
Your answer should be compact. 4.56e+07. What is the difference between the Aid flow (current US$) in Cameroon in 1988 and the Aid flow (current US$) in Equatorial Guinea in 1991?
Keep it short and to the point. 5.97e+06. What is the difference between the Aid flow (current US$) of East Asia (developing only) in 1989 and the Aid flow (current US$) of Argentina in 1990?
Give a very brief answer. 7.11e+07. What is the difference between the Aid flow (current US$) in East Asia (developing only) in 1989 and the Aid flow (current US$) in Cameroon in 1990?
Offer a terse response. 1.47e+08. What is the difference between the Aid flow (current US$) in East Asia (developing only) in 1989 and the Aid flow (current US$) in Equatorial Guinea in 1990?
Your answer should be compact. 1.53e+08. What is the difference between the Aid flow (current US$) in Argentina in 1989 and the Aid flow (current US$) in Cameroon in 1990?
Offer a very short reply. 1.09e+08. What is the difference between the Aid flow (current US$) in Argentina in 1989 and the Aid flow (current US$) in Equatorial Guinea in 1990?
Make the answer very short. 1.15e+08. What is the difference between the Aid flow (current US$) in Cameroon in 1989 and the Aid flow (current US$) in Equatorial Guinea in 1990?
Offer a terse response. 6.66e+07. What is the difference between the Aid flow (current US$) of East Asia (developing only) in 1989 and the Aid flow (current US$) of Cameroon in 1991?
Your answer should be compact. 1.42e+08. What is the difference between the Aid flow (current US$) of East Asia (developing only) in 1989 and the Aid flow (current US$) of Equatorial Guinea in 1991?
Provide a succinct answer. 1.52e+08. What is the difference between the Aid flow (current US$) in Argentina in 1989 and the Aid flow (current US$) in Cameroon in 1991?
Your answer should be very brief. 1.04e+08. What is the difference between the Aid flow (current US$) in Argentina in 1989 and the Aid flow (current US$) in Equatorial Guinea in 1991?
Provide a short and direct response. 1.13e+08. What is the difference between the Aid flow (current US$) in Cameroon in 1989 and the Aid flow (current US$) in Equatorial Guinea in 1991?
Give a very brief answer. 6.55e+07. What is the difference between the Aid flow (current US$) of East Asia (developing only) in 1990 and the Aid flow (current US$) of Argentina in 1991?
Ensure brevity in your answer.  -8.03e+07. What is the difference between the Aid flow (current US$) of East Asia (developing only) in 1990 and the Aid flow (current US$) of Cameroon in 1991?
Offer a terse response. 6.22e+07. What is the difference between the Aid flow (current US$) of East Asia (developing only) in 1990 and the Aid flow (current US$) of Equatorial Guinea in 1991?
Provide a succinct answer. 7.17e+07. What is the difference between the Aid flow (current US$) in Argentina in 1990 and the Aid flow (current US$) in Cameroon in 1991?
Provide a succinct answer. 7.13e+07. What is the difference between the Aid flow (current US$) in Argentina in 1990 and the Aid flow (current US$) in Equatorial Guinea in 1991?
Your answer should be compact. 8.07e+07. What is the difference between the Aid flow (current US$) of Cameroon in 1990 and the Aid flow (current US$) of Equatorial Guinea in 1991?
Make the answer very short. 4.81e+06. What is the average Aid flow (current US$) in East Asia (developing only) per year?
Keep it short and to the point. 8.27e+07. What is the average Aid flow (current US$) of Argentina per year?
Provide a succinct answer. 5.29e+07. What is the average Aid flow (current US$) of Cameroon per year?
Your response must be concise. 1.48e+07. What is the average Aid flow (current US$) of Equatorial Guinea per year?
Provide a succinct answer. 1.46e+06. In the year 1984, what is the difference between the Aid flow (current US$) in East Asia (developing only) and Aid flow (current US$) in Argentina?
Keep it short and to the point. 1.30e+07. In the year 1984, what is the difference between the Aid flow (current US$) of East Asia (developing only) and Aid flow (current US$) of Cameroon?
Offer a very short reply. 1.38e+07. In the year 1984, what is the difference between the Aid flow (current US$) in East Asia (developing only) and Aid flow (current US$) in Equatorial Guinea?
Ensure brevity in your answer.  1.60e+07. In the year 1984, what is the difference between the Aid flow (current US$) in Argentina and Aid flow (current US$) in Cameroon?
Your answer should be very brief. 7.30e+05. In the year 1984, what is the difference between the Aid flow (current US$) in Argentina and Aid flow (current US$) in Equatorial Guinea?
Ensure brevity in your answer.  2.98e+06. In the year 1984, what is the difference between the Aid flow (current US$) in Cameroon and Aid flow (current US$) in Equatorial Guinea?
Your answer should be very brief. 2.25e+06. In the year 1985, what is the difference between the Aid flow (current US$) in East Asia (developing only) and Aid flow (current US$) in Argentina?
Make the answer very short. 1.42e+07. In the year 1985, what is the difference between the Aid flow (current US$) in East Asia (developing only) and Aid flow (current US$) in Cameroon?
Your answer should be compact. 7.91e+06. In the year 1985, what is the difference between the Aid flow (current US$) in East Asia (developing only) and Aid flow (current US$) in Equatorial Guinea?
Make the answer very short. 1.74e+07. In the year 1985, what is the difference between the Aid flow (current US$) of Argentina and Aid flow (current US$) of Cameroon?
Keep it short and to the point. -6.25e+06. In the year 1985, what is the difference between the Aid flow (current US$) in Argentina and Aid flow (current US$) in Equatorial Guinea?
Your answer should be very brief. 3.20e+06. In the year 1985, what is the difference between the Aid flow (current US$) of Cameroon and Aid flow (current US$) of Equatorial Guinea?
Offer a very short reply. 9.45e+06. In the year 1986, what is the difference between the Aid flow (current US$) in East Asia (developing only) and Aid flow (current US$) in Argentina?
Provide a succinct answer. 5.50e+07. In the year 1986, what is the difference between the Aid flow (current US$) of East Asia (developing only) and Aid flow (current US$) of Cameroon?
Offer a very short reply. 5.25e+07. In the year 1986, what is the difference between the Aid flow (current US$) in East Asia (developing only) and Aid flow (current US$) in Equatorial Guinea?
Provide a succinct answer. 6.29e+07. In the year 1986, what is the difference between the Aid flow (current US$) in Argentina and Aid flow (current US$) in Cameroon?
Ensure brevity in your answer.  -2.48e+06. In the year 1986, what is the difference between the Aid flow (current US$) in Argentina and Aid flow (current US$) in Equatorial Guinea?
Your answer should be compact. 7.87e+06. In the year 1986, what is the difference between the Aid flow (current US$) of Cameroon and Aid flow (current US$) of Equatorial Guinea?
Ensure brevity in your answer.  1.04e+07. In the year 1987, what is the difference between the Aid flow (current US$) in East Asia (developing only) and Aid flow (current US$) in Argentina?
Offer a very short reply. 1.25e+08. In the year 1987, what is the difference between the Aid flow (current US$) of East Asia (developing only) and Aid flow (current US$) of Cameroon?
Provide a short and direct response. 1.32e+08. In the year 1987, what is the difference between the Aid flow (current US$) in East Asia (developing only) and Aid flow (current US$) in Equatorial Guinea?
Give a very brief answer. 1.31e+08. In the year 1987, what is the difference between the Aid flow (current US$) of Argentina and Aid flow (current US$) of Cameroon?
Offer a very short reply. 6.96e+06. In the year 1987, what is the difference between the Aid flow (current US$) of Argentina and Aid flow (current US$) of Equatorial Guinea?
Provide a short and direct response. 6.10e+06. In the year 1987, what is the difference between the Aid flow (current US$) of Cameroon and Aid flow (current US$) of Equatorial Guinea?
Your answer should be compact. -8.60e+05. In the year 1988, what is the difference between the Aid flow (current US$) of East Asia (developing only) and Aid flow (current US$) of Argentina?
Your response must be concise. 7.43e+07. In the year 1988, what is the difference between the Aid flow (current US$) of East Asia (developing only) and Aid flow (current US$) of Cameroon?
Keep it short and to the point. 1.14e+08. In the year 1988, what is the difference between the Aid flow (current US$) in East Asia (developing only) and Aid flow (current US$) in Equatorial Guinea?
Ensure brevity in your answer.  1.19e+08. In the year 1988, what is the difference between the Aid flow (current US$) of Argentina and Aid flow (current US$) of Cameroon?
Provide a short and direct response. 3.96e+07. In the year 1988, what is the difference between the Aid flow (current US$) of Argentina and Aid flow (current US$) of Equatorial Guinea?
Give a very brief answer. 4.45e+07. In the year 1988, what is the difference between the Aid flow (current US$) of Cameroon and Aid flow (current US$) of Equatorial Guinea?
Keep it short and to the point. 4.88e+06. In the year 1989, what is the difference between the Aid flow (current US$) of East Asia (developing only) and Aid flow (current US$) of Argentina?
Ensure brevity in your answer.  3.85e+07. In the year 1989, what is the difference between the Aid flow (current US$) of East Asia (developing only) and Aid flow (current US$) of Cameroon?
Offer a very short reply. 8.64e+07. In the year 1989, what is the difference between the Aid flow (current US$) in East Asia (developing only) and Aid flow (current US$) in Equatorial Guinea?
Ensure brevity in your answer.  1.51e+08. In the year 1989, what is the difference between the Aid flow (current US$) in Argentina and Aid flow (current US$) in Cameroon?
Keep it short and to the point. 4.79e+07. In the year 1989, what is the difference between the Aid flow (current US$) of Argentina and Aid flow (current US$) of Equatorial Guinea?
Your answer should be very brief. 1.13e+08. In the year 1989, what is the difference between the Aid flow (current US$) in Cameroon and Aid flow (current US$) in Equatorial Guinea?
Make the answer very short. 6.49e+07. In the year 1990, what is the difference between the Aid flow (current US$) of East Asia (developing only) and Aid flow (current US$) of Argentina?
Offer a terse response. -9.01e+06. In the year 1990, what is the difference between the Aid flow (current US$) of East Asia (developing only) and Aid flow (current US$) of Cameroon?
Keep it short and to the point. 6.69e+07. In the year 1990, what is the difference between the Aid flow (current US$) of East Asia (developing only) and Aid flow (current US$) of Equatorial Guinea?
Provide a succinct answer. 7.28e+07. In the year 1990, what is the difference between the Aid flow (current US$) of Argentina and Aid flow (current US$) of Cameroon?
Provide a succinct answer. 7.59e+07. In the year 1990, what is the difference between the Aid flow (current US$) of Argentina and Aid flow (current US$) of Equatorial Guinea?
Make the answer very short. 8.19e+07. In the year 1990, what is the difference between the Aid flow (current US$) of Cameroon and Aid flow (current US$) of Equatorial Guinea?
Offer a terse response. 5.96e+06. In the year 1991, what is the difference between the Aid flow (current US$) in East Asia (developing only) and Aid flow (current US$) in Argentina?
Offer a terse response. -7.26e+07. In the year 1991, what is the difference between the Aid flow (current US$) in East Asia (developing only) and Aid flow (current US$) in Cameroon?
Provide a short and direct response. 7.00e+07. In the year 1991, what is the difference between the Aid flow (current US$) in East Asia (developing only) and Aid flow (current US$) in Equatorial Guinea?
Your answer should be compact. 7.94e+07. In the year 1991, what is the difference between the Aid flow (current US$) in Argentina and Aid flow (current US$) in Cameroon?
Your answer should be compact. 1.43e+08. In the year 1991, what is the difference between the Aid flow (current US$) of Argentina and Aid flow (current US$) of Equatorial Guinea?
Keep it short and to the point. 1.52e+08. In the year 1991, what is the difference between the Aid flow (current US$) of Cameroon and Aid flow (current US$) of Equatorial Guinea?
Ensure brevity in your answer.  9.45e+06. What is the ratio of the Aid flow (current US$) in East Asia (developing only) in 1984 to that in 1985?
Give a very brief answer. 0.86. What is the ratio of the Aid flow (current US$) of Argentina in 1984 to that in 1985?
Your answer should be very brief. 0.68. What is the ratio of the Aid flow (current US$) of Cameroon in 1984 to that in 1985?
Your answer should be very brief. 0.21. What is the ratio of the Aid flow (current US$) in Equatorial Guinea in 1984 to that in 1985?
Make the answer very short. 0.01. What is the ratio of the Aid flow (current US$) of East Asia (developing only) in 1984 to that in 1986?
Make the answer very short. 0.25. What is the ratio of the Aid flow (current US$) of Argentina in 1984 to that in 1986?
Offer a very short reply. 0.32. What is the ratio of the Aid flow (current US$) of Cameroon in 1984 to that in 1986?
Make the answer very short. 0.19. What is the ratio of the Aid flow (current US$) of Equatorial Guinea in 1984 to that in 1986?
Provide a succinct answer. 0.01. What is the ratio of the Aid flow (current US$) in East Asia (developing only) in 1984 to that in 1987?
Provide a short and direct response. 0.12. What is the ratio of the Aid flow (current US$) in Argentina in 1984 to that in 1987?
Provide a short and direct response. 0.31. What is the ratio of the Aid flow (current US$) of Cameroon in 1984 to that in 1987?
Provide a succinct answer. 0.82. What is the ratio of the Aid flow (current US$) in Equatorial Guinea in 1984 to that in 1987?
Your response must be concise. 0. What is the ratio of the Aid flow (current US$) of East Asia (developing only) in 1984 to that in 1988?
Provide a short and direct response. 0.13. What is the ratio of the Aid flow (current US$) in Argentina in 1984 to that in 1988?
Keep it short and to the point. 0.06. What is the ratio of the Aid flow (current US$) of Cameroon in 1984 to that in 1988?
Give a very brief answer. 0.31. What is the ratio of the Aid flow (current US$) in Equatorial Guinea in 1984 to that in 1988?
Provide a succinct answer. 0. What is the ratio of the Aid flow (current US$) of East Asia (developing only) in 1984 to that in 1989?
Provide a short and direct response. 0.1. What is the ratio of the Aid flow (current US$) in Argentina in 1984 to that in 1989?
Provide a succinct answer. 0.03. What is the ratio of the Aid flow (current US$) of Cameroon in 1984 to that in 1989?
Your response must be concise. 0.03. What is the ratio of the Aid flow (current US$) in Equatorial Guinea in 1984 to that in 1989?
Ensure brevity in your answer.  0.01. What is the ratio of the Aid flow (current US$) in East Asia (developing only) in 1984 to that in 1990?
Your answer should be very brief. 0.22. What is the ratio of the Aid flow (current US$) of Argentina in 1984 to that in 1990?
Your answer should be very brief. 0.04. What is the ratio of the Aid flow (current US$) in Cameroon in 1984 to that in 1990?
Provide a short and direct response. 0.37. What is the ratio of the Aid flow (current US$) in Equatorial Guinea in 1984 to that in 1990?
Keep it short and to the point. 0.14. What is the ratio of the Aid flow (current US$) in East Asia (developing only) in 1984 to that in 1991?
Offer a very short reply. 0.2. What is the ratio of the Aid flow (current US$) in Argentina in 1984 to that in 1991?
Your answer should be very brief. 0.02. What is the ratio of the Aid flow (current US$) of Cameroon in 1984 to that in 1991?
Provide a succinct answer. 0.21. What is the ratio of the Aid flow (current US$) in Equatorial Guinea in 1984 to that in 1991?
Offer a very short reply. 0.01. What is the ratio of the Aid flow (current US$) in East Asia (developing only) in 1985 to that in 1986?
Keep it short and to the point. 0.29. What is the ratio of the Aid flow (current US$) in Argentina in 1985 to that in 1986?
Your answer should be very brief. 0.47. What is the ratio of the Aid flow (current US$) of Cameroon in 1985 to that in 1986?
Provide a short and direct response. 0.9. What is the ratio of the Aid flow (current US$) in Equatorial Guinea in 1985 to that in 1986?
Offer a very short reply. 0.79. What is the ratio of the Aid flow (current US$) of East Asia (developing only) in 1985 to that in 1987?
Ensure brevity in your answer.  0.14. What is the ratio of the Aid flow (current US$) of Argentina in 1985 to that in 1987?
Your response must be concise. 0.45. What is the ratio of the Aid flow (current US$) of Cameroon in 1985 to that in 1987?
Give a very brief answer. 3.84. What is the ratio of the Aid flow (current US$) in Equatorial Guinea in 1985 to that in 1987?
Ensure brevity in your answer.  0.33. What is the ratio of the Aid flow (current US$) of East Asia (developing only) in 1985 to that in 1988?
Give a very brief answer. 0.15. What is the ratio of the Aid flow (current US$) in Argentina in 1985 to that in 1988?
Keep it short and to the point. 0.09. What is the ratio of the Aid flow (current US$) of Cameroon in 1985 to that in 1988?
Your answer should be very brief. 1.48. What is the ratio of the Aid flow (current US$) of Equatorial Guinea in 1985 to that in 1988?
Make the answer very short. 0.51. What is the ratio of the Aid flow (current US$) in East Asia (developing only) in 1985 to that in 1989?
Keep it short and to the point. 0.12. What is the ratio of the Aid flow (current US$) in Argentina in 1985 to that in 1989?
Provide a succinct answer. 0.04. What is the ratio of the Aid flow (current US$) in Cameroon in 1985 to that in 1989?
Your answer should be compact. 0.16. What is the ratio of the Aid flow (current US$) of Equatorial Guinea in 1985 to that in 1989?
Your response must be concise. 0.66. What is the ratio of the Aid flow (current US$) of East Asia (developing only) in 1985 to that in 1990?
Make the answer very short. 0.25. What is the ratio of the Aid flow (current US$) in Argentina in 1985 to that in 1990?
Make the answer very short. 0.05. What is the ratio of the Aid flow (current US$) of Cameroon in 1985 to that in 1990?
Offer a terse response. 1.76. What is the ratio of the Aid flow (current US$) of Equatorial Guinea in 1985 to that in 1990?
Keep it short and to the point. 16.86. What is the ratio of the Aid flow (current US$) of East Asia (developing only) in 1985 to that in 1991?
Your answer should be compact. 0.23. What is the ratio of the Aid flow (current US$) of Argentina in 1985 to that in 1991?
Your response must be concise. 0.03. What is the ratio of the Aid flow (current US$) of Cameroon in 1985 to that in 1991?
Ensure brevity in your answer.  1. What is the ratio of the Aid flow (current US$) in Equatorial Guinea in 1985 to that in 1991?
Ensure brevity in your answer.  0.97. What is the ratio of the Aid flow (current US$) in East Asia (developing only) in 1986 to that in 1987?
Provide a succinct answer. 0.48. What is the ratio of the Aid flow (current US$) in Cameroon in 1986 to that in 1987?
Offer a very short reply. 4.28. What is the ratio of the Aid flow (current US$) of Equatorial Guinea in 1986 to that in 1987?
Provide a succinct answer. 0.41. What is the ratio of the Aid flow (current US$) of East Asia (developing only) in 1986 to that in 1988?
Your answer should be compact. 0.53. What is the ratio of the Aid flow (current US$) in Argentina in 1986 to that in 1988?
Your answer should be very brief. 0.2. What is the ratio of the Aid flow (current US$) of Cameroon in 1986 to that in 1988?
Ensure brevity in your answer.  1.65. What is the ratio of the Aid flow (current US$) of Equatorial Guinea in 1986 to that in 1988?
Keep it short and to the point. 0.65. What is the ratio of the Aid flow (current US$) of East Asia (developing only) in 1986 to that in 1989?
Your answer should be very brief. 0.42. What is the ratio of the Aid flow (current US$) in Argentina in 1986 to that in 1989?
Your answer should be compact. 0.08. What is the ratio of the Aid flow (current US$) in Cameroon in 1986 to that in 1989?
Your answer should be very brief. 0.18. What is the ratio of the Aid flow (current US$) of Equatorial Guinea in 1986 to that in 1989?
Make the answer very short. 0.84. What is the ratio of the Aid flow (current US$) of East Asia (developing only) in 1986 to that in 1990?
Keep it short and to the point. 0.88. What is the ratio of the Aid flow (current US$) of Argentina in 1986 to that in 1990?
Your answer should be compact. 0.11. What is the ratio of the Aid flow (current US$) of Cameroon in 1986 to that in 1990?
Your answer should be very brief. 1.97. What is the ratio of the Aid flow (current US$) in Equatorial Guinea in 1986 to that in 1990?
Offer a terse response. 21.43. What is the ratio of the Aid flow (current US$) in East Asia (developing only) in 1986 to that in 1991?
Give a very brief answer. 0.8. What is the ratio of the Aid flow (current US$) of Argentina in 1986 to that in 1991?
Your answer should be compact. 0.06. What is the ratio of the Aid flow (current US$) in Cameroon in 1986 to that in 1991?
Make the answer very short. 1.11. What is the ratio of the Aid flow (current US$) of Equatorial Guinea in 1986 to that in 1991?
Your answer should be very brief. 1.23. What is the ratio of the Aid flow (current US$) in East Asia (developing only) in 1987 to that in 1988?
Your response must be concise. 1.12. What is the ratio of the Aid flow (current US$) of Argentina in 1987 to that in 1988?
Make the answer very short. 0.21. What is the ratio of the Aid flow (current US$) in Cameroon in 1987 to that in 1988?
Your response must be concise. 0.39. What is the ratio of the Aid flow (current US$) in Equatorial Guinea in 1987 to that in 1988?
Keep it short and to the point. 1.57. What is the ratio of the Aid flow (current US$) in East Asia (developing only) in 1987 to that in 1989?
Offer a terse response. 0.88. What is the ratio of the Aid flow (current US$) in Argentina in 1987 to that in 1989?
Your answer should be very brief. 0.08. What is the ratio of the Aid flow (current US$) in Cameroon in 1987 to that in 1989?
Your answer should be compact. 0.04. What is the ratio of the Aid flow (current US$) in Equatorial Guinea in 1987 to that in 1989?
Your answer should be compact. 2.04. What is the ratio of the Aid flow (current US$) of East Asia (developing only) in 1987 to that in 1990?
Ensure brevity in your answer.  1.85. What is the ratio of the Aid flow (current US$) of Argentina in 1987 to that in 1990?
Your answer should be compact. 0.12. What is the ratio of the Aid flow (current US$) in Cameroon in 1987 to that in 1990?
Ensure brevity in your answer.  0.46. What is the ratio of the Aid flow (current US$) of Equatorial Guinea in 1987 to that in 1990?
Provide a short and direct response. 51.86. What is the ratio of the Aid flow (current US$) in East Asia (developing only) in 1987 to that in 1991?
Offer a very short reply. 1.68. What is the ratio of the Aid flow (current US$) in Argentina in 1987 to that in 1991?
Your answer should be very brief. 0.06. What is the ratio of the Aid flow (current US$) of Cameroon in 1987 to that in 1991?
Your answer should be compact. 0.26. What is the ratio of the Aid flow (current US$) of Equatorial Guinea in 1987 to that in 1991?
Your answer should be compact. 2.98. What is the ratio of the Aid flow (current US$) in East Asia (developing only) in 1988 to that in 1989?
Your answer should be compact. 0.79. What is the ratio of the Aid flow (current US$) of Argentina in 1988 to that in 1989?
Make the answer very short. 0.41. What is the ratio of the Aid flow (current US$) in Cameroon in 1988 to that in 1989?
Ensure brevity in your answer.  0.11. What is the ratio of the Aid flow (current US$) in Equatorial Guinea in 1988 to that in 1989?
Make the answer very short. 1.3. What is the ratio of the Aid flow (current US$) in East Asia (developing only) in 1988 to that in 1990?
Your answer should be very brief. 1.66. What is the ratio of the Aid flow (current US$) of Argentina in 1988 to that in 1990?
Provide a succinct answer. 0.57. What is the ratio of the Aid flow (current US$) in Cameroon in 1988 to that in 1990?
Make the answer very short. 1.19. What is the ratio of the Aid flow (current US$) in East Asia (developing only) in 1988 to that in 1991?
Keep it short and to the point. 1.5. What is the ratio of the Aid flow (current US$) of Argentina in 1988 to that in 1991?
Provide a succinct answer. 0.31. What is the ratio of the Aid flow (current US$) of Cameroon in 1988 to that in 1991?
Offer a terse response. 0.67. What is the ratio of the Aid flow (current US$) in Equatorial Guinea in 1988 to that in 1991?
Keep it short and to the point. 1.89. What is the ratio of the Aid flow (current US$) in East Asia (developing only) in 1989 to that in 1990?
Provide a succinct answer. 2.1. What is the ratio of the Aid flow (current US$) of Argentina in 1989 to that in 1990?
Keep it short and to the point. 1.4. What is the ratio of the Aid flow (current US$) in Cameroon in 1989 to that in 1990?
Provide a short and direct response. 11.06. What is the ratio of the Aid flow (current US$) of Equatorial Guinea in 1989 to that in 1990?
Give a very brief answer. 25.43. What is the ratio of the Aid flow (current US$) of East Asia (developing only) in 1989 to that in 1991?
Ensure brevity in your answer.  1.9. What is the ratio of the Aid flow (current US$) of Argentina in 1989 to that in 1991?
Your response must be concise. 0.75. What is the ratio of the Aid flow (current US$) in Cameroon in 1989 to that in 1991?
Offer a terse response. 6.25. What is the ratio of the Aid flow (current US$) of Equatorial Guinea in 1989 to that in 1991?
Provide a succinct answer. 1.46. What is the ratio of the Aid flow (current US$) in East Asia (developing only) in 1990 to that in 1991?
Your answer should be very brief. 0.9. What is the ratio of the Aid flow (current US$) of Argentina in 1990 to that in 1991?
Your answer should be very brief. 0.53. What is the ratio of the Aid flow (current US$) of Cameroon in 1990 to that in 1991?
Make the answer very short. 0.57. What is the ratio of the Aid flow (current US$) in Equatorial Guinea in 1990 to that in 1991?
Keep it short and to the point. 0.06. What is the difference between the highest and the second highest Aid flow (current US$) of East Asia (developing only)?
Offer a very short reply. 1.80e+07. What is the difference between the highest and the second highest Aid flow (current US$) of Argentina?
Offer a very short reply. 3.86e+07. What is the difference between the highest and the second highest Aid flow (current US$) in Cameroon?
Your response must be concise. 5.48e+07. What is the difference between the highest and the second highest Aid flow (current US$) in Equatorial Guinea?
Give a very brief answer. 1.32e+06. What is the difference between the highest and the lowest Aid flow (current US$) of East Asia (developing only)?
Your response must be concise. 1.37e+08. What is the difference between the highest and the lowest Aid flow (current US$) of Argentina?
Keep it short and to the point. 1.50e+08. What is the difference between the highest and the lowest Aid flow (current US$) of Cameroon?
Make the answer very short. 6.44e+07. What is the difference between the highest and the lowest Aid flow (current US$) of Equatorial Guinea?
Make the answer very short. 3.62e+06. 